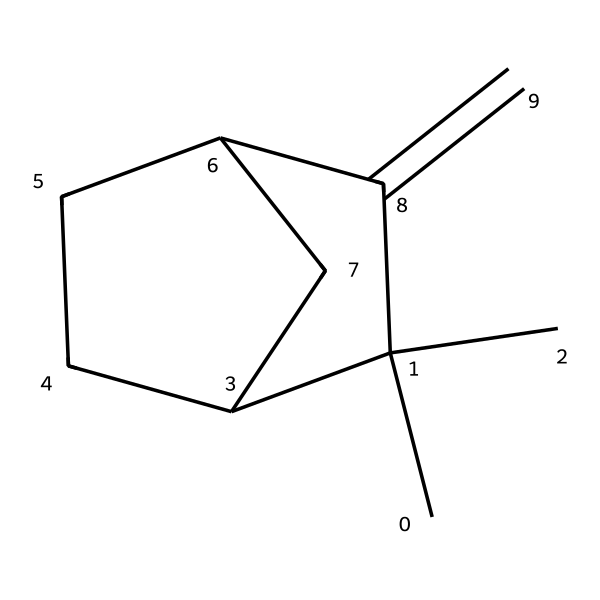How many carbon atoms are in camphene? By analyzing the SMILES representation, the structure indicates that there are seven carbon atoms present in total. Each "C" in the SMILES represents a carbon atom.
Answer: seven What is the molecular formula of camphene? To derive the molecular formula, count the carbon and hydrogen atoms from the structure: 10 hydrogens and 10 carbons result in the formula C10H16, considering the standard valency of carbon and how they bond.
Answer: C10H16 Is camphene a cyclic compound? Yes, the structure exhibits cyclical bonding, as evidenced by the presence of rings formed from carbon atoms, indicating it's a cyclic compound.
Answer: yes Identify a functional group present in camphene. Upon review, camphene does not have any defining functional groups like alcohols or acids, instead primarily exhibiting characteristics of terpenes, which are generally hydrocarbons.
Answer: none What type of chemical is camphene classified as? Camphene falls under the category of terpenes due to its structure and natural occurrence, commonly being recognized in essential oils.
Answer: terpene Does camphene have any unsaturation in its structure? The presence of a double bond in the ring structure indicates that camphene has unsaturation, which is characterized by fewer hydrogen atoms than the saturated counterpart.
Answer: yes 